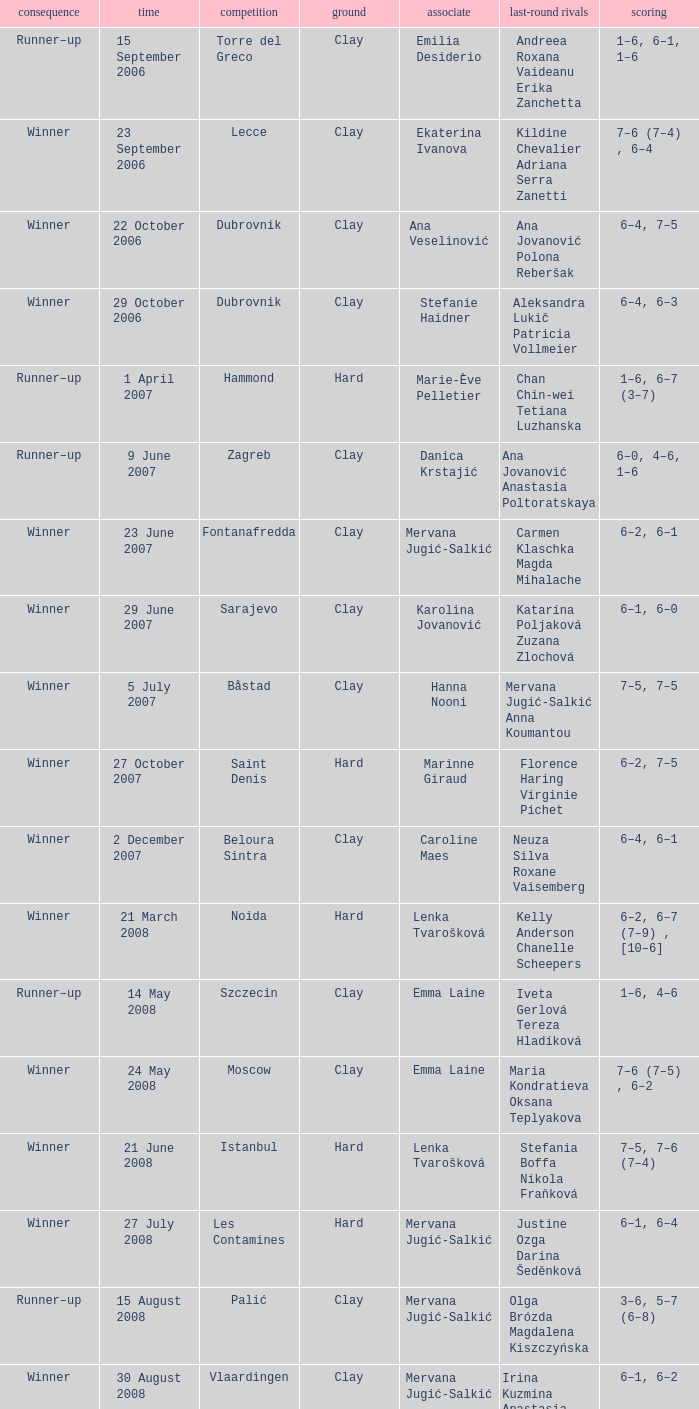Would you mind parsing the complete table? {'header': ['consequence', 'time', 'competition', 'ground', 'associate', 'last-round rivals', 'scoring'], 'rows': [['Runner–up', '15 September 2006', 'Torre del Greco', 'Clay', 'Emilia Desiderio', 'Andreea Roxana Vaideanu Erika Zanchetta', '1–6, 6–1, 1–6'], ['Winner', '23 September 2006', 'Lecce', 'Clay', 'Ekaterina Ivanova', 'Kildine Chevalier Adriana Serra Zanetti', '7–6 (7–4) , 6–4'], ['Winner', '22 October 2006', 'Dubrovnik', 'Clay', 'Ana Veselinović', 'Ana Jovanović Polona Reberšak', '6–4, 7–5'], ['Winner', '29 October 2006', 'Dubrovnik', 'Clay', 'Stefanie Haidner', 'Aleksandra Lukič Patricia Vollmeier', '6–4, 6–3'], ['Runner–up', '1 April 2007', 'Hammond', 'Hard', 'Marie-Ève Pelletier', 'Chan Chin-wei Tetiana Luzhanska', '1–6, 6–7 (3–7)'], ['Runner–up', '9 June 2007', 'Zagreb', 'Clay', 'Danica Krstajić', 'Ana Jovanović Anastasia Poltoratskaya', '6–0, 4–6, 1–6'], ['Winner', '23 June 2007', 'Fontanafredda', 'Clay', 'Mervana Jugić-Salkić', 'Carmen Klaschka Magda Mihalache', '6–2, 6–1'], ['Winner', '29 June 2007', 'Sarajevo', 'Clay', 'Karolina Jovanović', 'Katarína Poljaková Zuzana Zlochová', '6–1, 6–0'], ['Winner', '5 July 2007', 'Båstad', 'Clay', 'Hanna Nooni', 'Mervana Jugić-Salkić Anna Koumantou', '7–5, 7–5'], ['Winner', '27 October 2007', 'Saint Denis', 'Hard', 'Marinne Giraud', 'Florence Haring Virginie Pichet', '6–2, 7–5'], ['Winner', '2 December 2007', 'Beloura Sintra', 'Clay', 'Caroline Maes', 'Neuza Silva Roxane Vaisemberg', '6–4, 6–1'], ['Winner', '21 March 2008', 'Noida', 'Hard', 'Lenka Tvarošková', 'Kelly Anderson Chanelle Scheepers', '6–2, 6–7 (7–9) , [10–6]'], ['Runner–up', '14 May 2008', 'Szczecin', 'Clay', 'Emma Laine', 'Iveta Gerlová Tereza Hladíková', '1–6, 4–6'], ['Winner', '24 May 2008', 'Moscow', 'Clay', 'Emma Laine', 'Maria Kondratieva Oksana Teplyakova', '7–6 (7–5) , 6–2'], ['Winner', '21 June 2008', 'Istanbul', 'Hard', 'Lenka Tvarošková', 'Stefania Boffa Nikola Fraňková', '7–5, 7–6 (7–4)'], ['Winner', '27 July 2008', 'Les Contamines', 'Hard', 'Mervana Jugić-Salkić', 'Justine Ozga Darina Šeděnková', '6–1, 6–4'], ['Runner–up', '15 August 2008', 'Palić', 'Clay', 'Mervana Jugić-Salkić', 'Olga Brózda Magdalena Kiszczyńska', '3–6, 5–7 (6–8)'], ['Winner', '30 August 2008', 'Vlaardingen', 'Clay', 'Mervana Jugić-Salkić', 'Irina Kuzmina Anastasia Poltoratskaya', '6–1, 6–2'], ['Winner', '22 November 2008', 'Phoenix', 'Hard', 'Lenka Tvarošková', 'Kelly Anderson Natalie Grandin', '6–4, 3–6, [10–4]'], ['Winner', '12 April 2009', 'Šibenik', 'Clay', 'Nataša Zorić', 'Tina Obrez Mika Urbančič', '6–0, 6–3'], ['Winner', '17 July 2009', 'Rome', 'Clay', 'María Irigoyen', 'Elisa Balsamo Stefania Chieppa', '7–5, 6–2'], ['Winner', '5 September 2009', 'Brčko', 'Clay', 'Ana Jovanović', 'Patricia Chirea Petra Pajalič', '6–4, 6–1'], ['Runner–up', '13 September 2009', 'Denain', 'Clay', 'Magdalena Kiszchzynska', 'Elena Chalova Ksenia Lykina', '4–6, 3–6'], ['Runner–up', '10 October 2009', 'Podgorica', 'Clay', 'Karolina Jovanović', 'Nicole Clerico Karolina Kosińska', '7–6 (7–4) , 4–6, [4–10]'], ['Runner–up', '25 April 2010', 'Dothan', 'Clay', 'María Irigoyen', 'Alina Jidkova Anastasia Yakimova', '4–6, 2–6'], ['Winner', '12 June 2010', 'Budapest', 'Clay', 'Lenka Wienerová', 'Anna Livadaru Florencia Molinero', '6–4, 6–1'], ['Winner', '2 July 2010', 'Toruń', 'Clay', 'Marija Mirkovic', 'Katarzyna Piter Barbara Sobaszkiewicz', '4–6, 6–2, [10–5]'], ['Winner', '10 July 2010', 'Aschaffenburg', 'Clay', 'Erika Sema', 'Elena Bogdan Andrea Koch Benvenuto', '7–6 (7–4) , 2–6, [10–8]'], ['Runner–up', '6 August 2010', 'Moscow', 'Clay', 'Marija Mirkovic', 'Nadejda Guskova Valeria Solovyeva', '6–7 (5–7) , 3–6'], ['Runner–up', '15 January 2011', 'Glasgow', 'Hard (i)', 'Jasmina Tinjić', 'Ulrikke Eikeri Isabella Shinikova', '4–6, 4–6'], ['Winner', '12 February 2011', 'Antalya', 'Clay', 'Maria Shamayko', 'Sultan Gönen Anna Karavayeva', '6–4, 6–4'], ['Runner–up', '29 April 2011', 'Minsk', 'Hard (i)', 'Nicole Rottmann', 'Lyudmyla Kichenok Nadiya Kichenok', '1–6, 2–6'], ['Winner', '18 June 2011', 'Istanbul', 'Hard', 'Marta Domachowska', 'Daniella Dominikovic Melis Sezer', '6–4, 6–2'], ['Winners', '10 September 2011', 'Saransk', 'Clay', 'Mihaela Buzărnescu', 'Eva Hrdinová Veronika Kapshay', '6–3, 6–1'], ['Runner–up', '19-Mar-2012', 'Antalya', 'Clay', 'Claudia Giovine', 'Evelyn Mayr (ITA) Julia Mayr', '2-6,3-6'], ['Winner', '23-Apr-2012', 'San Severo', 'Clay', 'Anastasia Grymalska', 'Chiara Mendo Giulia Sussarello', '6-2 6-4'], ['Winners', '26 May 2012', 'Timișoara , Romania', 'Clay', 'Andreea Mitu', 'Lina Gjorcheska Dalia Zafirova', '6–1, 6–2'], ['Runner–up', '04-Jun-2012', 'Karshi , UZBEKISTAN', 'Clay', 'Veronika Kapshay', 'Valentyna Ivakhnenko Kateryna Kozlova', '5-7,3-6'], ['Winners', '25-Jun-2012', 'Izmir , TURKEY', 'Hard', 'Ana Bogdan', 'Abbie Myers Melis Sezer', '6-3, 3-0 RET'], ['Runner–up', '25-Jun-2012', 'Mestre , ITA', 'Clay', 'Reka-Luca Jani', 'Mailen Auroux Maria Irigoyen', '7-5,4-6 8-10'], ['Runner–up', '04-Feb-2013', 'Antalya , TURKEY', 'Clay', 'Ana Bogdan', 'Giulia Bruzzone Martina Caregaro', '3-6,6-1 6-10'], ['Winners', '11-Feb-2013', 'Antalya , TURKEY', 'Clay', 'Raluca Elena Platon', 'Ekaterine Gorgodze Sofia Kvatsabaia', '1-6 4-5 RET'], ['Winners', '01-Apr-2013', 'Heraklion , GRE', 'Carpet', 'Vivien Juhaszova', 'Giulia Sussarello Sara Sussarello', '7-5 6-7 (7) 10-4'], ['Winners', '08-Apr-2013', 'Heraklion , GRE', 'Carpet', 'Marina Melnikova', 'Giulia Sussarello Despina Papamichail', '6-1 6-4'], ['Winner', '13 May 2013', 'Balikpapan , Indonesia', 'Hard', 'Naomi Broady', 'Chen Yi Xu Yifan', '6–3, 6–3'], ['Winner', '20 May 2013', 'Tarakan , Indonesia', 'Hard (i)', 'Naomi Broady', 'Tang Haochen Tian Ran', '6–2, 1–6, [10–5]'], ['Runner–up', '03-Jun-2013', 'Karshi , Uzbekıstan', 'Clay', 'Veronika Kapshay', 'Margarita Gasparyan Polina Pekhova', '2-6,1-6'], ['Winner', '16 September 2013', 'Dobrich , Bulgaria', 'Clay', 'Xenia Knoll', 'Isabella Shinikova Dalia Zafirova', '7-5, 7–6(7–5)']]} Which tournament had a partner of Erika Sema? Aschaffenburg. 